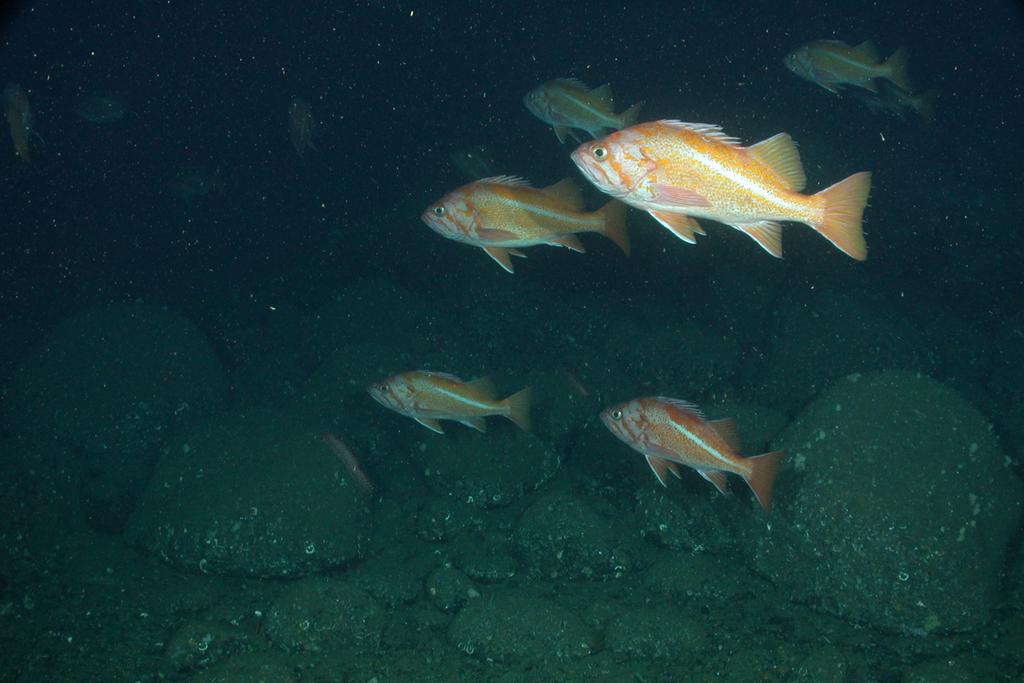What is the main subject in the center of the image? There is water in the center of the image. What can be found within the water? There are stones and fish in the water. Can you describe the fish in the image? The fish are orange and white in color. What type of mark can be seen on the fish in the image? There is no mark visible on the fish in the image. What kind of music is being played in the background of the image? There is no music present in the image; it is a still image of water, stones, and fish. 